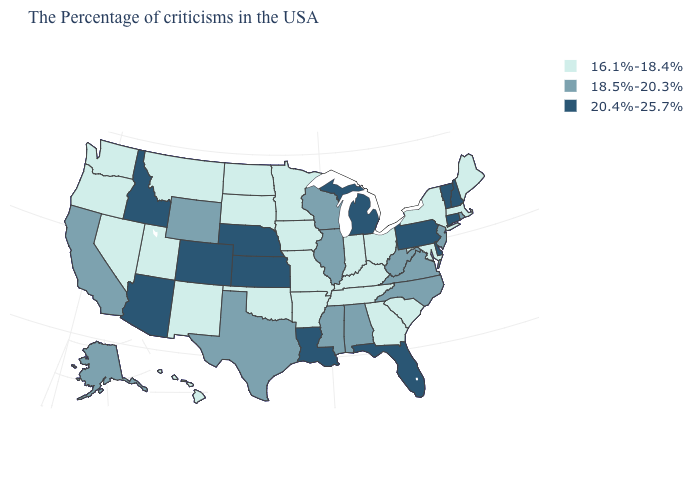What is the lowest value in the MidWest?
Keep it brief. 16.1%-18.4%. Name the states that have a value in the range 16.1%-18.4%?
Give a very brief answer. Maine, Massachusetts, New York, Maryland, South Carolina, Ohio, Georgia, Kentucky, Indiana, Tennessee, Missouri, Arkansas, Minnesota, Iowa, Oklahoma, South Dakota, North Dakota, New Mexico, Utah, Montana, Nevada, Washington, Oregon, Hawaii. What is the value of Utah?
Write a very short answer. 16.1%-18.4%. What is the value of Pennsylvania?
Give a very brief answer. 20.4%-25.7%. Does Iowa have the same value as Alabama?
Keep it brief. No. What is the value of North Carolina?
Answer briefly. 18.5%-20.3%. Name the states that have a value in the range 18.5%-20.3%?
Quick response, please. Rhode Island, New Jersey, Virginia, North Carolina, West Virginia, Alabama, Wisconsin, Illinois, Mississippi, Texas, Wyoming, California, Alaska. Does New Hampshire have the same value as Montana?
Keep it brief. No. How many symbols are there in the legend?
Give a very brief answer. 3. What is the value of Washington?
Concise answer only. 16.1%-18.4%. What is the value of Kentucky?
Quick response, please. 16.1%-18.4%. What is the lowest value in states that border Illinois?
Short answer required. 16.1%-18.4%. Does Vermont have the lowest value in the USA?
Be succinct. No. What is the lowest value in the South?
Short answer required. 16.1%-18.4%. How many symbols are there in the legend?
Quick response, please. 3. 